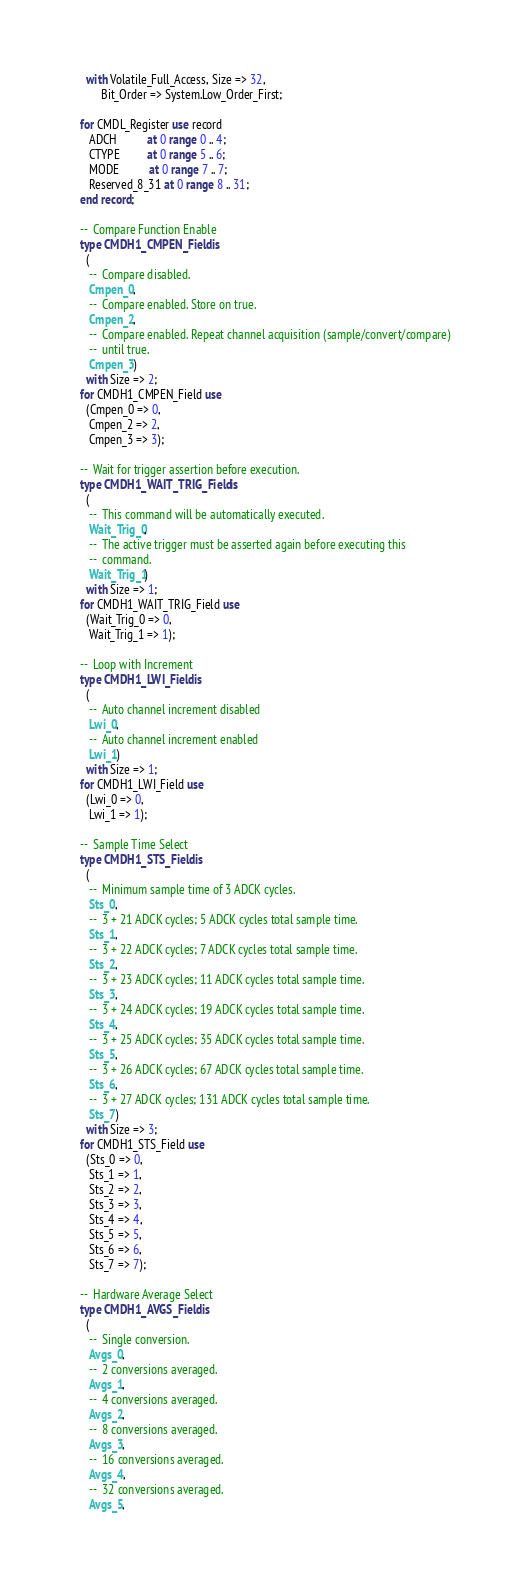Convert code to text. <code><loc_0><loc_0><loc_500><loc_500><_Ada_>     with Volatile_Full_Access, Size => 32,
          Bit_Order => System.Low_Order_First;

   for CMDL_Register use record
      ADCH          at 0 range 0 .. 4;
      CTYPE         at 0 range 5 .. 6;
      MODE          at 0 range 7 .. 7;
      Reserved_8_31 at 0 range 8 .. 31;
   end record;

   --  Compare Function Enable
   type CMDH1_CMPEN_Field is
     (
      --  Compare disabled.
      Cmpen_0,
      --  Compare enabled. Store on true.
      Cmpen_2,
      --  Compare enabled. Repeat channel acquisition (sample/convert/compare)
      --  until true.
      Cmpen_3)
     with Size => 2;
   for CMDH1_CMPEN_Field use
     (Cmpen_0 => 0,
      Cmpen_2 => 2,
      Cmpen_3 => 3);

   --  Wait for trigger assertion before execution.
   type CMDH1_WAIT_TRIG_Field is
     (
      --  This command will be automatically executed.
      Wait_Trig_0,
      --  The active trigger must be asserted again before executing this
      --  command.
      Wait_Trig_1)
     with Size => 1;
   for CMDH1_WAIT_TRIG_Field use
     (Wait_Trig_0 => 0,
      Wait_Trig_1 => 1);

   --  Loop with Increment
   type CMDH1_LWI_Field is
     (
      --  Auto channel increment disabled
      Lwi_0,
      --  Auto channel increment enabled
      Lwi_1)
     with Size => 1;
   for CMDH1_LWI_Field use
     (Lwi_0 => 0,
      Lwi_1 => 1);

   --  Sample Time Select
   type CMDH1_STS_Field is
     (
      --  Minimum sample time of 3 ADCK cycles.
      Sts_0,
      --  3 + 21 ADCK cycles; 5 ADCK cycles total sample time.
      Sts_1,
      --  3 + 22 ADCK cycles; 7 ADCK cycles total sample time.
      Sts_2,
      --  3 + 23 ADCK cycles; 11 ADCK cycles total sample time.
      Sts_3,
      --  3 + 24 ADCK cycles; 19 ADCK cycles total sample time.
      Sts_4,
      --  3 + 25 ADCK cycles; 35 ADCK cycles total sample time.
      Sts_5,
      --  3 + 26 ADCK cycles; 67 ADCK cycles total sample time.
      Sts_6,
      --  3 + 27 ADCK cycles; 131 ADCK cycles total sample time.
      Sts_7)
     with Size => 3;
   for CMDH1_STS_Field use
     (Sts_0 => 0,
      Sts_1 => 1,
      Sts_2 => 2,
      Sts_3 => 3,
      Sts_4 => 4,
      Sts_5 => 5,
      Sts_6 => 6,
      Sts_7 => 7);

   --  Hardware Average Select
   type CMDH1_AVGS_Field is
     (
      --  Single conversion.
      Avgs_0,
      --  2 conversions averaged.
      Avgs_1,
      --  4 conversions averaged.
      Avgs_2,
      --  8 conversions averaged.
      Avgs_3,
      --  16 conversions averaged.
      Avgs_4,
      --  32 conversions averaged.
      Avgs_5,</code> 